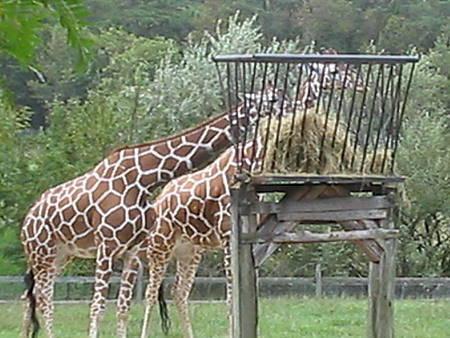How many giraffes are visible?
Give a very brief answer. 2. How many people are interacting with their mobile phones?
Give a very brief answer. 0. 